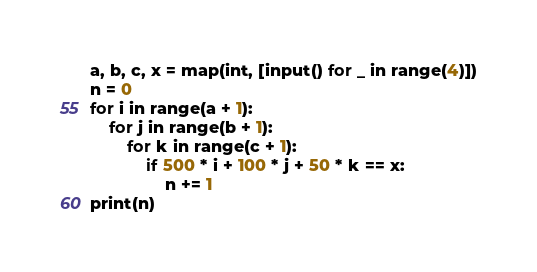<code> <loc_0><loc_0><loc_500><loc_500><_Python_>a, b, c, x = map(int, [input() for _ in range(4)])
n = 0
for i in range(a + 1):
    for j in range(b + 1):
        for k in range(c + 1):
            if 500 * i + 100 * j + 50 * k == x:
                n += 1
print(n)</code> 